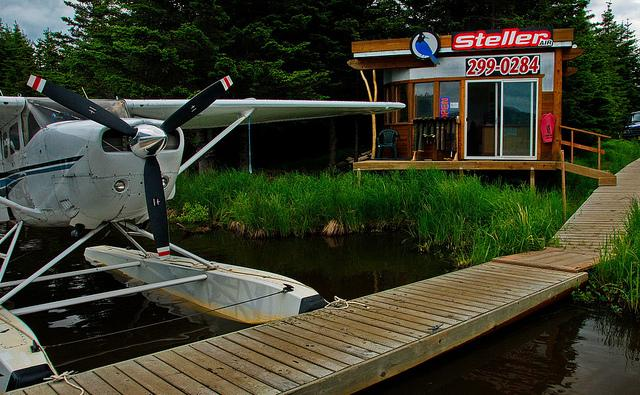What rhymes with the name of the store and is found on the vehicle? propeller 